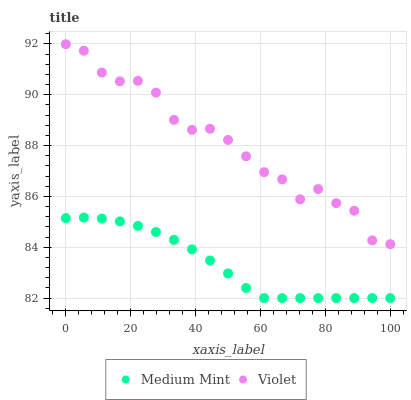Does Medium Mint have the minimum area under the curve?
Answer yes or no. Yes. Does Violet have the maximum area under the curve?
Answer yes or no. Yes. Does Violet have the minimum area under the curve?
Answer yes or no. No. Is Medium Mint the smoothest?
Answer yes or no. Yes. Is Violet the roughest?
Answer yes or no. Yes. Is Violet the smoothest?
Answer yes or no. No. Does Medium Mint have the lowest value?
Answer yes or no. Yes. Does Violet have the lowest value?
Answer yes or no. No. Does Violet have the highest value?
Answer yes or no. Yes. Is Medium Mint less than Violet?
Answer yes or no. Yes. Is Violet greater than Medium Mint?
Answer yes or no. Yes. Does Medium Mint intersect Violet?
Answer yes or no. No. 